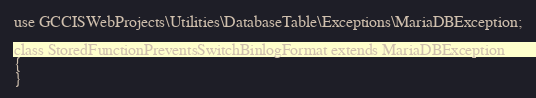<code> <loc_0><loc_0><loc_500><loc_500><_PHP_>
use GCCISWebProjects\Utilities\DatabaseTable\Exceptions\MariaDBException;

class StoredFunctionPreventsSwitchBinlogFormat extends MariaDBException
{
}
</code> 